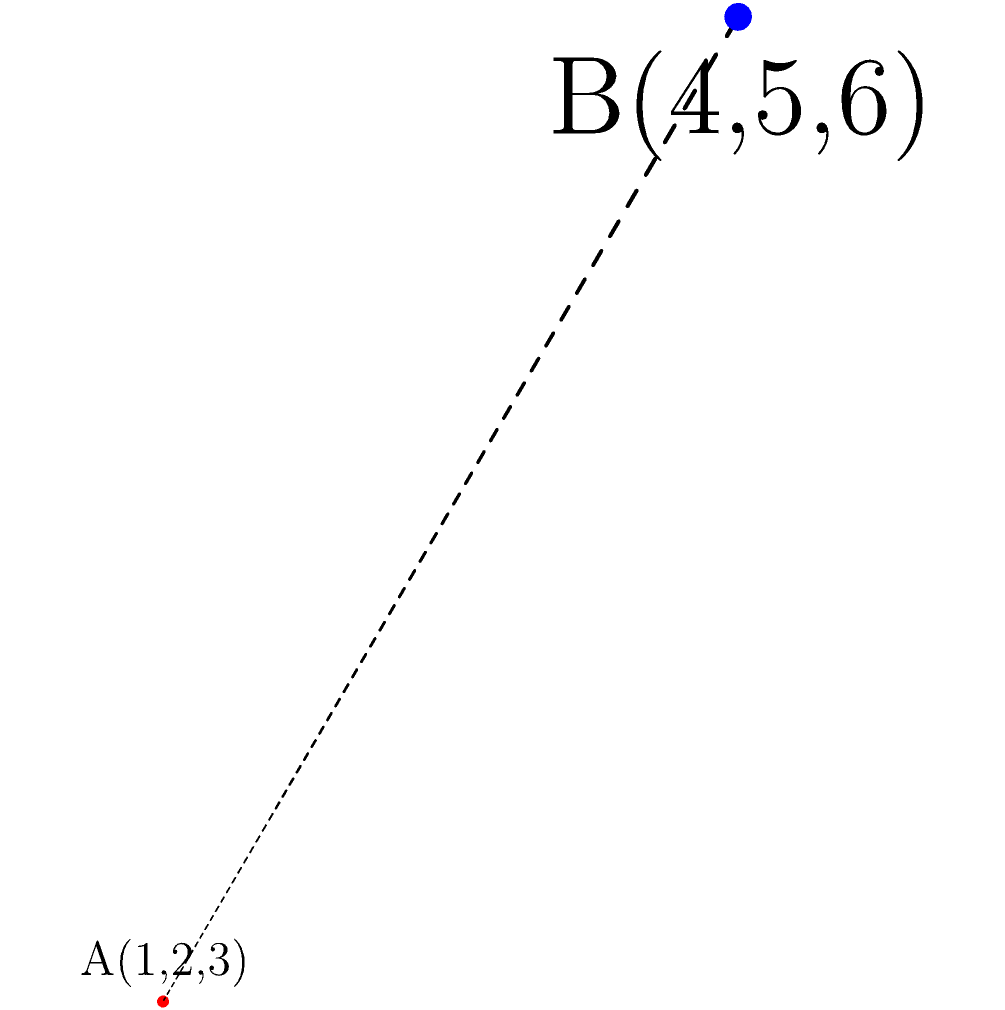Given two points in 3D space, A(1,2,3) and B(4,5,6), calculate the distance between them using the distance formula for 3D points. Round your answer to two decimal places. To calculate the distance between two points in 3D space, we use the following formula:

$$ d = \sqrt{(x_2-x_1)^2 + (y_2-y_1)^2 + (z_2-z_1)^2} $$

Where $(x_1,y_1,z_1)$ are the coordinates of the first point and $(x_2,y_2,z_2)$ are the coordinates of the second point.

Let's solve this step by step:

1. Identify the coordinates:
   A(1,2,3): $x_1=1$, $y_1=2$, $z_1=3$
   B(4,5,6): $x_2=4$, $y_2=5$, $z_2=6$

2. Calculate the differences:
   $x_2-x_1 = 4-1 = 3$
   $y_2-y_1 = 5-2 = 3$
   $z_2-z_1 = 6-3 = 3$

3. Square each difference:
   $(x_2-x_1)^2 = 3^2 = 9$
   $(y_2-y_1)^2 = 3^2 = 9$
   $(z_2-z_1)^2 = 3^2 = 9$

4. Sum the squared differences:
   $9 + 9 + 9 = 27$

5. Take the square root:
   $\sqrt{27} \approx 5.196152422706632$

6. Round to two decimal places:
   $5.20$

Therefore, the distance between points A and B is approximately 5.20 units.
Answer: 5.20 